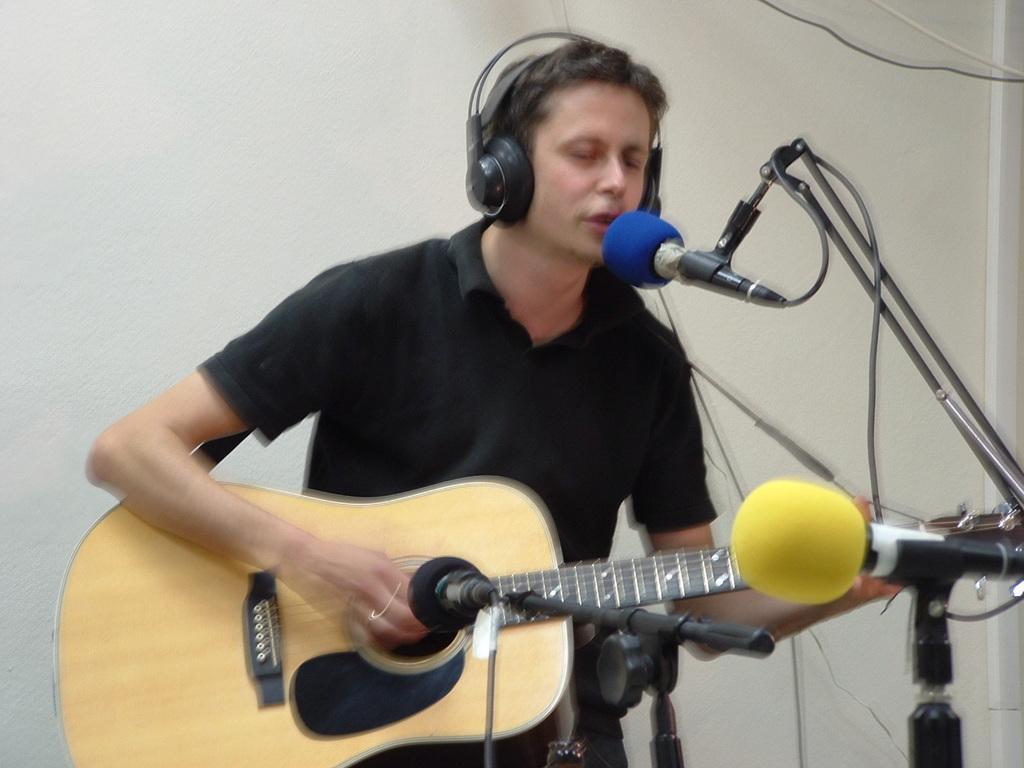Describe this image in one or two sentences. In this image I see a man who is standing in front of the mics and he is holding a guitar and he is wearing a headphone and I can also see he is wearing a black T shirt. In the background I see the wall. 